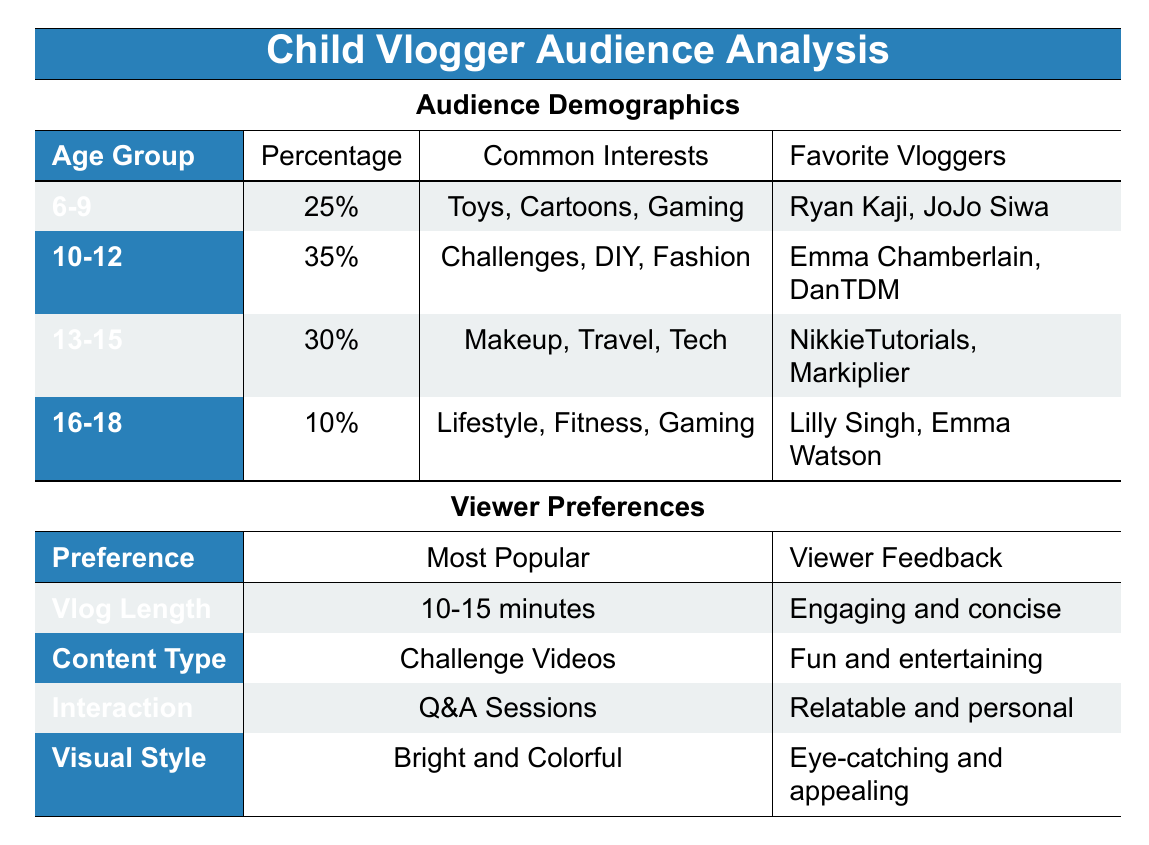What percentage of the audience is between 10-12 years old? The table shows that the percentage for the age group 10-12 is listed directly. It states 35% for that age group.
Answer: 35% Which age group has the highest percentage of the audience? By comparing the percentages in the age groups, 10-12 has the highest at 35%.
Answer: 10-12 Do viewers prefer longer vlogs? Looking at the Viewer Preferences section, the information indicates that the most popular vlog length is 10-15 minutes, which suggests that viewers prefer concise vlogs rather than longer ones.
Answer: No What are the common interests of the 13-15 age group? The table directly lists the common interests for the age group 13-15 as Makeup, Travel, and Tech.
Answer: Makeup, Travel, Tech What is the total percentage of viewers who are 16 and younger? To find the percentage of viewers 16 and younger, we sum the percentages of the age groups 6-9, 10-12, and 13-15. Adding 25% (6-9), 35% (10-12), and 30% (13-15) results in 90%.
Answer: 90% Is "Q&A Sessions" the preferred interaction type for viewers? The table reveals that Q&A Sessions is indeed the most popular interaction type listed under Viewer Preferences, confirming that it is preferred by viewers.
Answer: Yes What demographics might a vlogger targeting gaming content focus on? Analyzing the demographics, the age groups 6-9 and 16-18 both show interests in gaming. The 6-9 age group is 25% and the 16-18 age group is 10%, thus these demographics cover younger viewers who enjoy gaming content.
Answer: 6-9 and 16-18 What is the least preferred age demographic for vlogger content? By reviewing the audience demographics, 16-18 has the lowest percentage at 10%, indicating it is the least preferred age demographic for vlogger content.
Answer: 16-18 Which type of content is the most popular among viewers? The table indicates that Challenge Videos are the most popular type of content preferred by the viewers.
Answer: Challenge Videos 